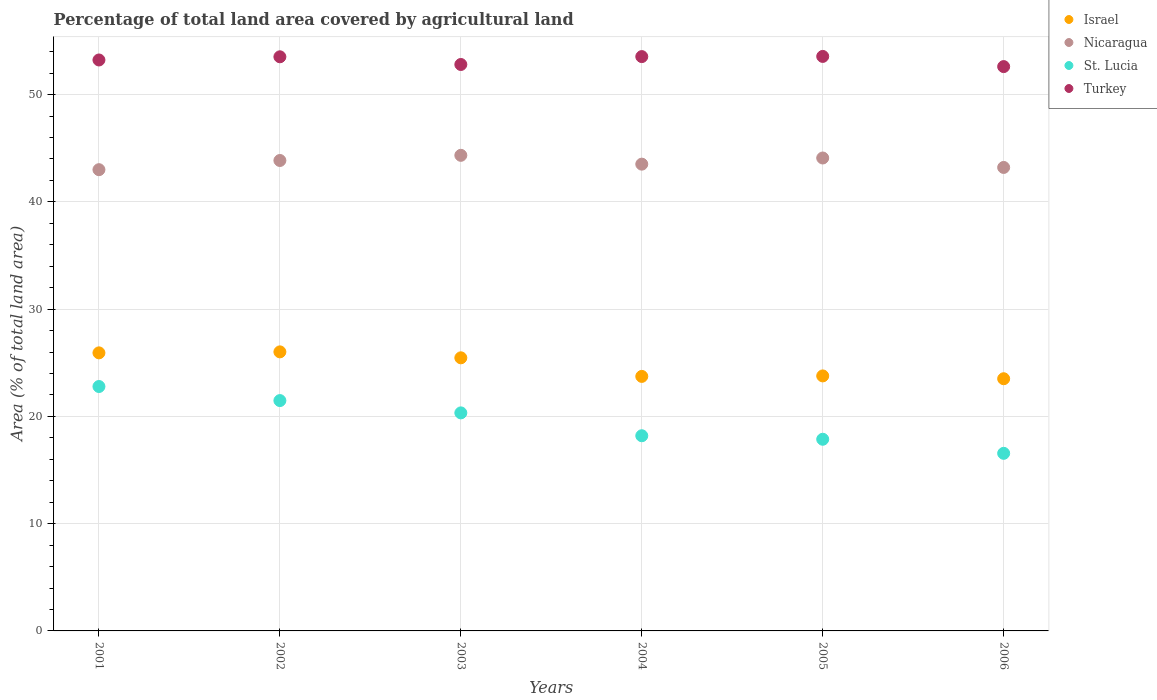What is the percentage of agricultural land in St. Lucia in 2001?
Make the answer very short. 22.79. Across all years, what is the maximum percentage of agricultural land in Turkey?
Your answer should be compact. 53.56. Across all years, what is the minimum percentage of agricultural land in Israel?
Make the answer very short. 23.51. In which year was the percentage of agricultural land in Nicaragua maximum?
Provide a succinct answer. 2003. In which year was the percentage of agricultural land in Turkey minimum?
Give a very brief answer. 2006. What is the total percentage of agricultural land in Nicaragua in the graph?
Your answer should be very brief. 262.02. What is the difference between the percentage of agricultural land in Turkey in 2001 and that in 2003?
Make the answer very short. 0.42. What is the difference between the percentage of agricultural land in Nicaragua in 2004 and the percentage of agricultural land in Turkey in 2001?
Offer a terse response. -9.71. What is the average percentage of agricultural land in St. Lucia per year?
Offer a terse response. 19.54. In the year 2002, what is the difference between the percentage of agricultural land in Israel and percentage of agricultural land in Nicaragua?
Your answer should be very brief. -17.84. What is the ratio of the percentage of agricultural land in Israel in 2001 to that in 2006?
Give a very brief answer. 1.1. Is the percentage of agricultural land in Turkey in 2005 less than that in 2006?
Your response must be concise. No. What is the difference between the highest and the second highest percentage of agricultural land in Turkey?
Keep it short and to the point. 0.02. What is the difference between the highest and the lowest percentage of agricultural land in Israel?
Ensure brevity in your answer.  2.5. Is the percentage of agricultural land in Nicaragua strictly less than the percentage of agricultural land in Israel over the years?
Keep it short and to the point. No. How many years are there in the graph?
Your answer should be compact. 6. How many legend labels are there?
Your answer should be very brief. 4. What is the title of the graph?
Offer a very short reply. Percentage of total land area covered by agricultural land. Does "Peru" appear as one of the legend labels in the graph?
Ensure brevity in your answer.  No. What is the label or title of the X-axis?
Keep it short and to the point. Years. What is the label or title of the Y-axis?
Ensure brevity in your answer.  Area (% of total land area). What is the Area (% of total land area) of Israel in 2001?
Offer a terse response. 25.92. What is the Area (% of total land area) in Nicaragua in 2001?
Offer a terse response. 43. What is the Area (% of total land area) in St. Lucia in 2001?
Offer a terse response. 22.79. What is the Area (% of total land area) of Turkey in 2001?
Provide a short and direct response. 53.23. What is the Area (% of total land area) of Israel in 2002?
Keep it short and to the point. 26.02. What is the Area (% of total land area) of Nicaragua in 2002?
Your answer should be compact. 43.86. What is the Area (% of total land area) in St. Lucia in 2002?
Make the answer very short. 21.48. What is the Area (% of total land area) of Turkey in 2002?
Provide a succinct answer. 53.53. What is the Area (% of total land area) of Israel in 2003?
Offer a terse response. 25.46. What is the Area (% of total land area) of Nicaragua in 2003?
Provide a succinct answer. 44.34. What is the Area (% of total land area) in St. Lucia in 2003?
Offer a very short reply. 20.33. What is the Area (% of total land area) of Turkey in 2003?
Ensure brevity in your answer.  52.81. What is the Area (% of total land area) of Israel in 2004?
Keep it short and to the point. 23.73. What is the Area (% of total land area) in Nicaragua in 2004?
Provide a succinct answer. 43.52. What is the Area (% of total land area) in St. Lucia in 2004?
Your response must be concise. 18.2. What is the Area (% of total land area) of Turkey in 2004?
Your answer should be very brief. 53.55. What is the Area (% of total land area) of Israel in 2005?
Keep it short and to the point. 23.78. What is the Area (% of total land area) of Nicaragua in 2005?
Your answer should be very brief. 44.09. What is the Area (% of total land area) in St. Lucia in 2005?
Your answer should be very brief. 17.87. What is the Area (% of total land area) in Turkey in 2005?
Your answer should be compact. 53.56. What is the Area (% of total land area) of Israel in 2006?
Your response must be concise. 23.51. What is the Area (% of total land area) of Nicaragua in 2006?
Your answer should be compact. 43.21. What is the Area (% of total land area) in St. Lucia in 2006?
Offer a very short reply. 16.56. What is the Area (% of total land area) in Turkey in 2006?
Your answer should be very brief. 52.61. Across all years, what is the maximum Area (% of total land area) of Israel?
Provide a succinct answer. 26.02. Across all years, what is the maximum Area (% of total land area) of Nicaragua?
Your answer should be compact. 44.34. Across all years, what is the maximum Area (% of total land area) in St. Lucia?
Your answer should be very brief. 22.79. Across all years, what is the maximum Area (% of total land area) in Turkey?
Make the answer very short. 53.56. Across all years, what is the minimum Area (% of total land area) of Israel?
Offer a terse response. 23.51. Across all years, what is the minimum Area (% of total land area) in Nicaragua?
Your answer should be very brief. 43. Across all years, what is the minimum Area (% of total land area) of St. Lucia?
Ensure brevity in your answer.  16.56. Across all years, what is the minimum Area (% of total land area) in Turkey?
Keep it short and to the point. 52.61. What is the total Area (% of total land area) in Israel in the graph?
Your answer should be compact. 148.42. What is the total Area (% of total land area) in Nicaragua in the graph?
Make the answer very short. 262.02. What is the total Area (% of total land area) of St. Lucia in the graph?
Make the answer very short. 117.21. What is the total Area (% of total land area) of Turkey in the graph?
Offer a terse response. 319.29. What is the difference between the Area (% of total land area) in Israel in 2001 and that in 2002?
Your answer should be very brief. -0.09. What is the difference between the Area (% of total land area) of Nicaragua in 2001 and that in 2002?
Ensure brevity in your answer.  -0.86. What is the difference between the Area (% of total land area) in St. Lucia in 2001 and that in 2002?
Make the answer very short. 1.31. What is the difference between the Area (% of total land area) of Turkey in 2001 and that in 2002?
Your response must be concise. -0.3. What is the difference between the Area (% of total land area) in Israel in 2001 and that in 2003?
Your answer should be compact. 0.46. What is the difference between the Area (% of total land area) in Nicaragua in 2001 and that in 2003?
Provide a short and direct response. -1.34. What is the difference between the Area (% of total land area) in St. Lucia in 2001 and that in 2003?
Provide a succinct answer. 2.46. What is the difference between the Area (% of total land area) in Turkey in 2001 and that in 2003?
Your answer should be very brief. 0.42. What is the difference between the Area (% of total land area) in Israel in 2001 and that in 2004?
Ensure brevity in your answer.  2.19. What is the difference between the Area (% of total land area) in Nicaragua in 2001 and that in 2004?
Keep it short and to the point. -0.52. What is the difference between the Area (% of total land area) in St. Lucia in 2001 and that in 2004?
Ensure brevity in your answer.  4.59. What is the difference between the Area (% of total land area) in Turkey in 2001 and that in 2004?
Give a very brief answer. -0.31. What is the difference between the Area (% of total land area) in Israel in 2001 and that in 2005?
Provide a succinct answer. 2.15. What is the difference between the Area (% of total land area) of Nicaragua in 2001 and that in 2005?
Give a very brief answer. -1.09. What is the difference between the Area (% of total land area) in St. Lucia in 2001 and that in 2005?
Provide a succinct answer. 4.92. What is the difference between the Area (% of total land area) in Turkey in 2001 and that in 2005?
Your response must be concise. -0.33. What is the difference between the Area (% of total land area) of Israel in 2001 and that in 2006?
Your answer should be very brief. 2.41. What is the difference between the Area (% of total land area) of Nicaragua in 2001 and that in 2006?
Your answer should be very brief. -0.21. What is the difference between the Area (% of total land area) of St. Lucia in 2001 and that in 2006?
Your response must be concise. 6.23. What is the difference between the Area (% of total land area) in Turkey in 2001 and that in 2006?
Give a very brief answer. 0.62. What is the difference between the Area (% of total land area) of Israel in 2002 and that in 2003?
Keep it short and to the point. 0.55. What is the difference between the Area (% of total land area) in Nicaragua in 2002 and that in 2003?
Keep it short and to the point. -0.48. What is the difference between the Area (% of total land area) of St. Lucia in 2002 and that in 2003?
Offer a terse response. 1.15. What is the difference between the Area (% of total land area) of Turkey in 2002 and that in 2003?
Keep it short and to the point. 0.72. What is the difference between the Area (% of total land area) in Israel in 2002 and that in 2004?
Provide a short and direct response. 2.29. What is the difference between the Area (% of total land area) in Nicaragua in 2002 and that in 2004?
Your response must be concise. 0.34. What is the difference between the Area (% of total land area) of St. Lucia in 2002 and that in 2004?
Give a very brief answer. 3.28. What is the difference between the Area (% of total land area) in Turkey in 2002 and that in 2004?
Your answer should be compact. -0.02. What is the difference between the Area (% of total land area) of Israel in 2002 and that in 2005?
Ensure brevity in your answer.  2.24. What is the difference between the Area (% of total land area) of Nicaragua in 2002 and that in 2005?
Your response must be concise. -0.23. What is the difference between the Area (% of total land area) in St. Lucia in 2002 and that in 2005?
Provide a succinct answer. 3.61. What is the difference between the Area (% of total land area) of Turkey in 2002 and that in 2005?
Your response must be concise. -0.04. What is the difference between the Area (% of total land area) of Israel in 2002 and that in 2006?
Provide a short and direct response. 2.5. What is the difference between the Area (% of total land area) of Nicaragua in 2002 and that in 2006?
Keep it short and to the point. 0.65. What is the difference between the Area (% of total land area) in St. Lucia in 2002 and that in 2006?
Offer a very short reply. 4.92. What is the difference between the Area (% of total land area) in Turkey in 2002 and that in 2006?
Keep it short and to the point. 0.91. What is the difference between the Area (% of total land area) in Israel in 2003 and that in 2004?
Offer a very short reply. 1.73. What is the difference between the Area (% of total land area) of Nicaragua in 2003 and that in 2004?
Make the answer very short. 0.82. What is the difference between the Area (% of total land area) in St. Lucia in 2003 and that in 2004?
Provide a short and direct response. 2.13. What is the difference between the Area (% of total land area) of Turkey in 2003 and that in 2004?
Give a very brief answer. -0.74. What is the difference between the Area (% of total land area) of Israel in 2003 and that in 2005?
Offer a terse response. 1.69. What is the difference between the Area (% of total land area) of Nicaragua in 2003 and that in 2005?
Ensure brevity in your answer.  0.25. What is the difference between the Area (% of total land area) in St. Lucia in 2003 and that in 2005?
Your answer should be compact. 2.46. What is the difference between the Area (% of total land area) in Turkey in 2003 and that in 2005?
Keep it short and to the point. -0.75. What is the difference between the Area (% of total land area) in Israel in 2003 and that in 2006?
Provide a short and direct response. 1.95. What is the difference between the Area (% of total land area) of Nicaragua in 2003 and that in 2006?
Provide a short and direct response. 1.13. What is the difference between the Area (% of total land area) of St. Lucia in 2003 and that in 2006?
Keep it short and to the point. 3.77. What is the difference between the Area (% of total land area) of Turkey in 2003 and that in 2006?
Give a very brief answer. 0.2. What is the difference between the Area (% of total land area) of Israel in 2004 and that in 2005?
Provide a short and direct response. -0.05. What is the difference between the Area (% of total land area) of Nicaragua in 2004 and that in 2005?
Provide a succinct answer. -0.57. What is the difference between the Area (% of total land area) in St. Lucia in 2004 and that in 2005?
Your answer should be very brief. 0.33. What is the difference between the Area (% of total land area) of Turkey in 2004 and that in 2005?
Give a very brief answer. -0.02. What is the difference between the Area (% of total land area) in Israel in 2004 and that in 2006?
Make the answer very short. 0.22. What is the difference between the Area (% of total land area) of Nicaragua in 2004 and that in 2006?
Provide a short and direct response. 0.31. What is the difference between the Area (% of total land area) in St. Lucia in 2004 and that in 2006?
Your response must be concise. 1.64. What is the difference between the Area (% of total land area) of Turkey in 2004 and that in 2006?
Your response must be concise. 0.93. What is the difference between the Area (% of total land area) in Israel in 2005 and that in 2006?
Ensure brevity in your answer.  0.26. What is the difference between the Area (% of total land area) of Nicaragua in 2005 and that in 2006?
Offer a terse response. 0.88. What is the difference between the Area (% of total land area) in St. Lucia in 2005 and that in 2006?
Provide a short and direct response. 1.31. What is the difference between the Area (% of total land area) of Turkey in 2005 and that in 2006?
Ensure brevity in your answer.  0.95. What is the difference between the Area (% of total land area) of Israel in 2001 and the Area (% of total land area) of Nicaragua in 2002?
Provide a short and direct response. -17.93. What is the difference between the Area (% of total land area) in Israel in 2001 and the Area (% of total land area) in St. Lucia in 2002?
Make the answer very short. 4.45. What is the difference between the Area (% of total land area) in Israel in 2001 and the Area (% of total land area) in Turkey in 2002?
Ensure brevity in your answer.  -27.6. What is the difference between the Area (% of total land area) in Nicaragua in 2001 and the Area (% of total land area) in St. Lucia in 2002?
Provide a short and direct response. 21.53. What is the difference between the Area (% of total land area) of Nicaragua in 2001 and the Area (% of total land area) of Turkey in 2002?
Provide a short and direct response. -10.52. What is the difference between the Area (% of total land area) of St. Lucia in 2001 and the Area (% of total land area) of Turkey in 2002?
Make the answer very short. -30.74. What is the difference between the Area (% of total land area) of Israel in 2001 and the Area (% of total land area) of Nicaragua in 2003?
Your answer should be compact. -18.42. What is the difference between the Area (% of total land area) in Israel in 2001 and the Area (% of total land area) in St. Lucia in 2003?
Your answer should be compact. 5.6. What is the difference between the Area (% of total land area) of Israel in 2001 and the Area (% of total land area) of Turkey in 2003?
Offer a terse response. -26.89. What is the difference between the Area (% of total land area) in Nicaragua in 2001 and the Area (% of total land area) in St. Lucia in 2003?
Your answer should be very brief. 22.68. What is the difference between the Area (% of total land area) in Nicaragua in 2001 and the Area (% of total land area) in Turkey in 2003?
Give a very brief answer. -9.81. What is the difference between the Area (% of total land area) of St. Lucia in 2001 and the Area (% of total land area) of Turkey in 2003?
Keep it short and to the point. -30.02. What is the difference between the Area (% of total land area) of Israel in 2001 and the Area (% of total land area) of Nicaragua in 2004?
Ensure brevity in your answer.  -17.59. What is the difference between the Area (% of total land area) of Israel in 2001 and the Area (% of total land area) of St. Lucia in 2004?
Offer a very short reply. 7.73. What is the difference between the Area (% of total land area) in Israel in 2001 and the Area (% of total land area) in Turkey in 2004?
Your response must be concise. -27.62. What is the difference between the Area (% of total land area) of Nicaragua in 2001 and the Area (% of total land area) of St. Lucia in 2004?
Make the answer very short. 24.81. What is the difference between the Area (% of total land area) of Nicaragua in 2001 and the Area (% of total land area) of Turkey in 2004?
Your response must be concise. -10.54. What is the difference between the Area (% of total land area) of St. Lucia in 2001 and the Area (% of total land area) of Turkey in 2004?
Ensure brevity in your answer.  -30.76. What is the difference between the Area (% of total land area) of Israel in 2001 and the Area (% of total land area) of Nicaragua in 2005?
Keep it short and to the point. -18.17. What is the difference between the Area (% of total land area) in Israel in 2001 and the Area (% of total land area) in St. Lucia in 2005?
Offer a terse response. 8.06. What is the difference between the Area (% of total land area) of Israel in 2001 and the Area (% of total land area) of Turkey in 2005?
Your response must be concise. -27.64. What is the difference between the Area (% of total land area) of Nicaragua in 2001 and the Area (% of total land area) of St. Lucia in 2005?
Your answer should be compact. 25.13. What is the difference between the Area (% of total land area) in Nicaragua in 2001 and the Area (% of total land area) in Turkey in 2005?
Your answer should be very brief. -10.56. What is the difference between the Area (% of total land area) of St. Lucia in 2001 and the Area (% of total land area) of Turkey in 2005?
Provide a succinct answer. -30.78. What is the difference between the Area (% of total land area) in Israel in 2001 and the Area (% of total land area) in Nicaragua in 2006?
Make the answer very short. -17.29. What is the difference between the Area (% of total land area) in Israel in 2001 and the Area (% of total land area) in St. Lucia in 2006?
Your answer should be compact. 9.37. What is the difference between the Area (% of total land area) in Israel in 2001 and the Area (% of total land area) in Turkey in 2006?
Your response must be concise. -26.69. What is the difference between the Area (% of total land area) in Nicaragua in 2001 and the Area (% of total land area) in St. Lucia in 2006?
Provide a succinct answer. 26.45. What is the difference between the Area (% of total land area) of Nicaragua in 2001 and the Area (% of total land area) of Turkey in 2006?
Keep it short and to the point. -9.61. What is the difference between the Area (% of total land area) of St. Lucia in 2001 and the Area (% of total land area) of Turkey in 2006?
Make the answer very short. -29.83. What is the difference between the Area (% of total land area) of Israel in 2002 and the Area (% of total land area) of Nicaragua in 2003?
Your answer should be compact. -18.32. What is the difference between the Area (% of total land area) in Israel in 2002 and the Area (% of total land area) in St. Lucia in 2003?
Offer a very short reply. 5.69. What is the difference between the Area (% of total land area) in Israel in 2002 and the Area (% of total land area) in Turkey in 2003?
Your response must be concise. -26.79. What is the difference between the Area (% of total land area) in Nicaragua in 2002 and the Area (% of total land area) in St. Lucia in 2003?
Ensure brevity in your answer.  23.53. What is the difference between the Area (% of total land area) in Nicaragua in 2002 and the Area (% of total land area) in Turkey in 2003?
Give a very brief answer. -8.95. What is the difference between the Area (% of total land area) of St. Lucia in 2002 and the Area (% of total land area) of Turkey in 2003?
Your response must be concise. -31.33. What is the difference between the Area (% of total land area) in Israel in 2002 and the Area (% of total land area) in Nicaragua in 2004?
Your answer should be compact. -17.5. What is the difference between the Area (% of total land area) of Israel in 2002 and the Area (% of total land area) of St. Lucia in 2004?
Offer a terse response. 7.82. What is the difference between the Area (% of total land area) in Israel in 2002 and the Area (% of total land area) in Turkey in 2004?
Provide a short and direct response. -27.53. What is the difference between the Area (% of total land area) of Nicaragua in 2002 and the Area (% of total land area) of St. Lucia in 2004?
Your response must be concise. 25.66. What is the difference between the Area (% of total land area) in Nicaragua in 2002 and the Area (% of total land area) in Turkey in 2004?
Give a very brief answer. -9.69. What is the difference between the Area (% of total land area) in St. Lucia in 2002 and the Area (% of total land area) in Turkey in 2004?
Make the answer very short. -32.07. What is the difference between the Area (% of total land area) in Israel in 2002 and the Area (% of total land area) in Nicaragua in 2005?
Ensure brevity in your answer.  -18.08. What is the difference between the Area (% of total land area) in Israel in 2002 and the Area (% of total land area) in St. Lucia in 2005?
Offer a very short reply. 8.15. What is the difference between the Area (% of total land area) of Israel in 2002 and the Area (% of total land area) of Turkey in 2005?
Your response must be concise. -27.55. What is the difference between the Area (% of total land area) in Nicaragua in 2002 and the Area (% of total land area) in St. Lucia in 2005?
Offer a very short reply. 25.99. What is the difference between the Area (% of total land area) in Nicaragua in 2002 and the Area (% of total land area) in Turkey in 2005?
Your response must be concise. -9.7. What is the difference between the Area (% of total land area) of St. Lucia in 2002 and the Area (% of total land area) of Turkey in 2005?
Your answer should be very brief. -32.09. What is the difference between the Area (% of total land area) in Israel in 2002 and the Area (% of total land area) in Nicaragua in 2006?
Your answer should be very brief. -17.19. What is the difference between the Area (% of total land area) of Israel in 2002 and the Area (% of total land area) of St. Lucia in 2006?
Your answer should be compact. 9.46. What is the difference between the Area (% of total land area) in Israel in 2002 and the Area (% of total land area) in Turkey in 2006?
Your answer should be very brief. -26.6. What is the difference between the Area (% of total land area) in Nicaragua in 2002 and the Area (% of total land area) in St. Lucia in 2006?
Ensure brevity in your answer.  27.3. What is the difference between the Area (% of total land area) in Nicaragua in 2002 and the Area (% of total land area) in Turkey in 2006?
Your response must be concise. -8.75. What is the difference between the Area (% of total land area) of St. Lucia in 2002 and the Area (% of total land area) of Turkey in 2006?
Provide a short and direct response. -31.14. What is the difference between the Area (% of total land area) in Israel in 2003 and the Area (% of total land area) in Nicaragua in 2004?
Provide a short and direct response. -18.06. What is the difference between the Area (% of total land area) in Israel in 2003 and the Area (% of total land area) in St. Lucia in 2004?
Ensure brevity in your answer.  7.27. What is the difference between the Area (% of total land area) of Israel in 2003 and the Area (% of total land area) of Turkey in 2004?
Your answer should be very brief. -28.08. What is the difference between the Area (% of total land area) in Nicaragua in 2003 and the Area (% of total land area) in St. Lucia in 2004?
Offer a terse response. 26.14. What is the difference between the Area (% of total land area) of Nicaragua in 2003 and the Area (% of total land area) of Turkey in 2004?
Offer a very short reply. -9.2. What is the difference between the Area (% of total land area) in St. Lucia in 2003 and the Area (% of total land area) in Turkey in 2004?
Provide a succinct answer. -33.22. What is the difference between the Area (% of total land area) of Israel in 2003 and the Area (% of total land area) of Nicaragua in 2005?
Your answer should be very brief. -18.63. What is the difference between the Area (% of total land area) in Israel in 2003 and the Area (% of total land area) in St. Lucia in 2005?
Your response must be concise. 7.59. What is the difference between the Area (% of total land area) in Israel in 2003 and the Area (% of total land area) in Turkey in 2005?
Offer a very short reply. -28.1. What is the difference between the Area (% of total land area) of Nicaragua in 2003 and the Area (% of total land area) of St. Lucia in 2005?
Your answer should be compact. 26.47. What is the difference between the Area (% of total land area) of Nicaragua in 2003 and the Area (% of total land area) of Turkey in 2005?
Offer a very short reply. -9.22. What is the difference between the Area (% of total land area) of St. Lucia in 2003 and the Area (% of total land area) of Turkey in 2005?
Give a very brief answer. -33.23. What is the difference between the Area (% of total land area) of Israel in 2003 and the Area (% of total land area) of Nicaragua in 2006?
Provide a short and direct response. -17.75. What is the difference between the Area (% of total land area) of Israel in 2003 and the Area (% of total land area) of St. Lucia in 2006?
Give a very brief answer. 8.9. What is the difference between the Area (% of total land area) in Israel in 2003 and the Area (% of total land area) in Turkey in 2006?
Provide a succinct answer. -27.15. What is the difference between the Area (% of total land area) of Nicaragua in 2003 and the Area (% of total land area) of St. Lucia in 2006?
Your answer should be very brief. 27.78. What is the difference between the Area (% of total land area) of Nicaragua in 2003 and the Area (% of total land area) of Turkey in 2006?
Make the answer very short. -8.27. What is the difference between the Area (% of total land area) of St. Lucia in 2003 and the Area (% of total land area) of Turkey in 2006?
Give a very brief answer. -32.29. What is the difference between the Area (% of total land area) in Israel in 2004 and the Area (% of total land area) in Nicaragua in 2005?
Your answer should be compact. -20.36. What is the difference between the Area (% of total land area) in Israel in 2004 and the Area (% of total land area) in St. Lucia in 2005?
Your answer should be very brief. 5.86. What is the difference between the Area (% of total land area) of Israel in 2004 and the Area (% of total land area) of Turkey in 2005?
Provide a succinct answer. -29.83. What is the difference between the Area (% of total land area) in Nicaragua in 2004 and the Area (% of total land area) in St. Lucia in 2005?
Give a very brief answer. 25.65. What is the difference between the Area (% of total land area) of Nicaragua in 2004 and the Area (% of total land area) of Turkey in 2005?
Ensure brevity in your answer.  -10.04. What is the difference between the Area (% of total land area) of St. Lucia in 2004 and the Area (% of total land area) of Turkey in 2005?
Your answer should be compact. -35.37. What is the difference between the Area (% of total land area) of Israel in 2004 and the Area (% of total land area) of Nicaragua in 2006?
Ensure brevity in your answer.  -19.48. What is the difference between the Area (% of total land area) of Israel in 2004 and the Area (% of total land area) of St. Lucia in 2006?
Give a very brief answer. 7.17. What is the difference between the Area (% of total land area) in Israel in 2004 and the Area (% of total land area) in Turkey in 2006?
Your answer should be very brief. -28.88. What is the difference between the Area (% of total land area) in Nicaragua in 2004 and the Area (% of total land area) in St. Lucia in 2006?
Provide a short and direct response. 26.96. What is the difference between the Area (% of total land area) in Nicaragua in 2004 and the Area (% of total land area) in Turkey in 2006?
Offer a very short reply. -9.1. What is the difference between the Area (% of total land area) of St. Lucia in 2004 and the Area (% of total land area) of Turkey in 2006?
Keep it short and to the point. -34.42. What is the difference between the Area (% of total land area) in Israel in 2005 and the Area (% of total land area) in Nicaragua in 2006?
Provide a succinct answer. -19.44. What is the difference between the Area (% of total land area) of Israel in 2005 and the Area (% of total land area) of St. Lucia in 2006?
Make the answer very short. 7.22. What is the difference between the Area (% of total land area) in Israel in 2005 and the Area (% of total land area) in Turkey in 2006?
Make the answer very short. -28.84. What is the difference between the Area (% of total land area) of Nicaragua in 2005 and the Area (% of total land area) of St. Lucia in 2006?
Your answer should be very brief. 27.53. What is the difference between the Area (% of total land area) in Nicaragua in 2005 and the Area (% of total land area) in Turkey in 2006?
Provide a succinct answer. -8.52. What is the difference between the Area (% of total land area) of St. Lucia in 2005 and the Area (% of total land area) of Turkey in 2006?
Offer a very short reply. -34.74. What is the average Area (% of total land area) in Israel per year?
Your answer should be compact. 24.74. What is the average Area (% of total land area) of Nicaragua per year?
Offer a very short reply. 43.67. What is the average Area (% of total land area) in St. Lucia per year?
Keep it short and to the point. 19.54. What is the average Area (% of total land area) of Turkey per year?
Provide a succinct answer. 53.21. In the year 2001, what is the difference between the Area (% of total land area) in Israel and Area (% of total land area) in Nicaragua?
Your answer should be compact. -17.08. In the year 2001, what is the difference between the Area (% of total land area) in Israel and Area (% of total land area) in St. Lucia?
Your response must be concise. 3.14. In the year 2001, what is the difference between the Area (% of total land area) of Israel and Area (% of total land area) of Turkey?
Offer a very short reply. -27.31. In the year 2001, what is the difference between the Area (% of total land area) of Nicaragua and Area (% of total land area) of St. Lucia?
Your response must be concise. 20.22. In the year 2001, what is the difference between the Area (% of total land area) in Nicaragua and Area (% of total land area) in Turkey?
Provide a succinct answer. -10.23. In the year 2001, what is the difference between the Area (% of total land area) in St. Lucia and Area (% of total land area) in Turkey?
Give a very brief answer. -30.44. In the year 2002, what is the difference between the Area (% of total land area) in Israel and Area (% of total land area) in Nicaragua?
Your answer should be very brief. -17.84. In the year 2002, what is the difference between the Area (% of total land area) of Israel and Area (% of total land area) of St. Lucia?
Your response must be concise. 4.54. In the year 2002, what is the difference between the Area (% of total land area) of Israel and Area (% of total land area) of Turkey?
Offer a very short reply. -27.51. In the year 2002, what is the difference between the Area (% of total land area) of Nicaragua and Area (% of total land area) of St. Lucia?
Provide a short and direct response. 22.38. In the year 2002, what is the difference between the Area (% of total land area) in Nicaragua and Area (% of total land area) in Turkey?
Keep it short and to the point. -9.67. In the year 2002, what is the difference between the Area (% of total land area) of St. Lucia and Area (% of total land area) of Turkey?
Offer a terse response. -32.05. In the year 2003, what is the difference between the Area (% of total land area) in Israel and Area (% of total land area) in Nicaragua?
Give a very brief answer. -18.88. In the year 2003, what is the difference between the Area (% of total land area) in Israel and Area (% of total land area) in St. Lucia?
Your answer should be compact. 5.13. In the year 2003, what is the difference between the Area (% of total land area) in Israel and Area (% of total land area) in Turkey?
Ensure brevity in your answer.  -27.35. In the year 2003, what is the difference between the Area (% of total land area) of Nicaragua and Area (% of total land area) of St. Lucia?
Give a very brief answer. 24.01. In the year 2003, what is the difference between the Area (% of total land area) of Nicaragua and Area (% of total land area) of Turkey?
Give a very brief answer. -8.47. In the year 2003, what is the difference between the Area (% of total land area) of St. Lucia and Area (% of total land area) of Turkey?
Make the answer very short. -32.48. In the year 2004, what is the difference between the Area (% of total land area) in Israel and Area (% of total land area) in Nicaragua?
Your answer should be compact. -19.79. In the year 2004, what is the difference between the Area (% of total land area) of Israel and Area (% of total land area) of St. Lucia?
Provide a succinct answer. 5.53. In the year 2004, what is the difference between the Area (% of total land area) of Israel and Area (% of total land area) of Turkey?
Ensure brevity in your answer.  -29.82. In the year 2004, what is the difference between the Area (% of total land area) of Nicaragua and Area (% of total land area) of St. Lucia?
Ensure brevity in your answer.  25.32. In the year 2004, what is the difference between the Area (% of total land area) in Nicaragua and Area (% of total land area) in Turkey?
Ensure brevity in your answer.  -10.03. In the year 2004, what is the difference between the Area (% of total land area) in St. Lucia and Area (% of total land area) in Turkey?
Your answer should be compact. -35.35. In the year 2005, what is the difference between the Area (% of total land area) of Israel and Area (% of total land area) of Nicaragua?
Offer a very short reply. -20.32. In the year 2005, what is the difference between the Area (% of total land area) in Israel and Area (% of total land area) in St. Lucia?
Your answer should be very brief. 5.91. In the year 2005, what is the difference between the Area (% of total land area) of Israel and Area (% of total land area) of Turkey?
Offer a terse response. -29.79. In the year 2005, what is the difference between the Area (% of total land area) in Nicaragua and Area (% of total land area) in St. Lucia?
Offer a very short reply. 26.22. In the year 2005, what is the difference between the Area (% of total land area) in Nicaragua and Area (% of total land area) in Turkey?
Provide a succinct answer. -9.47. In the year 2005, what is the difference between the Area (% of total land area) of St. Lucia and Area (% of total land area) of Turkey?
Provide a succinct answer. -35.69. In the year 2006, what is the difference between the Area (% of total land area) in Israel and Area (% of total land area) in Nicaragua?
Your answer should be very brief. -19.7. In the year 2006, what is the difference between the Area (% of total land area) of Israel and Area (% of total land area) of St. Lucia?
Your response must be concise. 6.95. In the year 2006, what is the difference between the Area (% of total land area) of Israel and Area (% of total land area) of Turkey?
Give a very brief answer. -29.1. In the year 2006, what is the difference between the Area (% of total land area) of Nicaragua and Area (% of total land area) of St. Lucia?
Your answer should be very brief. 26.65. In the year 2006, what is the difference between the Area (% of total land area) of Nicaragua and Area (% of total land area) of Turkey?
Give a very brief answer. -9.4. In the year 2006, what is the difference between the Area (% of total land area) in St. Lucia and Area (% of total land area) in Turkey?
Give a very brief answer. -36.06. What is the ratio of the Area (% of total land area) in Israel in 2001 to that in 2002?
Give a very brief answer. 1. What is the ratio of the Area (% of total land area) of Nicaragua in 2001 to that in 2002?
Your answer should be very brief. 0.98. What is the ratio of the Area (% of total land area) of St. Lucia in 2001 to that in 2002?
Make the answer very short. 1.06. What is the ratio of the Area (% of total land area) of Israel in 2001 to that in 2003?
Your answer should be very brief. 1.02. What is the ratio of the Area (% of total land area) in Nicaragua in 2001 to that in 2003?
Ensure brevity in your answer.  0.97. What is the ratio of the Area (% of total land area) of St. Lucia in 2001 to that in 2003?
Your answer should be compact. 1.12. What is the ratio of the Area (% of total land area) of Turkey in 2001 to that in 2003?
Your response must be concise. 1.01. What is the ratio of the Area (% of total land area) of Israel in 2001 to that in 2004?
Offer a terse response. 1.09. What is the ratio of the Area (% of total land area) of St. Lucia in 2001 to that in 2004?
Ensure brevity in your answer.  1.25. What is the ratio of the Area (% of total land area) in Turkey in 2001 to that in 2004?
Offer a terse response. 0.99. What is the ratio of the Area (% of total land area) in Israel in 2001 to that in 2005?
Give a very brief answer. 1.09. What is the ratio of the Area (% of total land area) of Nicaragua in 2001 to that in 2005?
Keep it short and to the point. 0.98. What is the ratio of the Area (% of total land area) of St. Lucia in 2001 to that in 2005?
Your response must be concise. 1.28. What is the ratio of the Area (% of total land area) in Turkey in 2001 to that in 2005?
Ensure brevity in your answer.  0.99. What is the ratio of the Area (% of total land area) in Israel in 2001 to that in 2006?
Provide a succinct answer. 1.1. What is the ratio of the Area (% of total land area) of St. Lucia in 2001 to that in 2006?
Your answer should be very brief. 1.38. What is the ratio of the Area (% of total land area) in Turkey in 2001 to that in 2006?
Offer a very short reply. 1.01. What is the ratio of the Area (% of total land area) in Israel in 2002 to that in 2003?
Give a very brief answer. 1.02. What is the ratio of the Area (% of total land area) of Nicaragua in 2002 to that in 2003?
Ensure brevity in your answer.  0.99. What is the ratio of the Area (% of total land area) in St. Lucia in 2002 to that in 2003?
Give a very brief answer. 1.06. What is the ratio of the Area (% of total land area) of Turkey in 2002 to that in 2003?
Provide a succinct answer. 1.01. What is the ratio of the Area (% of total land area) in Israel in 2002 to that in 2004?
Offer a very short reply. 1.1. What is the ratio of the Area (% of total land area) in Nicaragua in 2002 to that in 2004?
Provide a short and direct response. 1.01. What is the ratio of the Area (% of total land area) of St. Lucia in 2002 to that in 2004?
Make the answer very short. 1.18. What is the ratio of the Area (% of total land area) in Israel in 2002 to that in 2005?
Your answer should be compact. 1.09. What is the ratio of the Area (% of total land area) of Nicaragua in 2002 to that in 2005?
Provide a short and direct response. 0.99. What is the ratio of the Area (% of total land area) in St. Lucia in 2002 to that in 2005?
Ensure brevity in your answer.  1.2. What is the ratio of the Area (% of total land area) of Israel in 2002 to that in 2006?
Give a very brief answer. 1.11. What is the ratio of the Area (% of total land area) of Nicaragua in 2002 to that in 2006?
Your answer should be compact. 1.01. What is the ratio of the Area (% of total land area) in St. Lucia in 2002 to that in 2006?
Offer a terse response. 1.3. What is the ratio of the Area (% of total land area) of Turkey in 2002 to that in 2006?
Offer a very short reply. 1.02. What is the ratio of the Area (% of total land area) in Israel in 2003 to that in 2004?
Make the answer very short. 1.07. What is the ratio of the Area (% of total land area) of Nicaragua in 2003 to that in 2004?
Your answer should be compact. 1.02. What is the ratio of the Area (% of total land area) of St. Lucia in 2003 to that in 2004?
Your answer should be compact. 1.12. What is the ratio of the Area (% of total land area) of Turkey in 2003 to that in 2004?
Your answer should be compact. 0.99. What is the ratio of the Area (% of total land area) in Israel in 2003 to that in 2005?
Offer a very short reply. 1.07. What is the ratio of the Area (% of total land area) in Nicaragua in 2003 to that in 2005?
Provide a short and direct response. 1.01. What is the ratio of the Area (% of total land area) of St. Lucia in 2003 to that in 2005?
Offer a very short reply. 1.14. What is the ratio of the Area (% of total land area) of Israel in 2003 to that in 2006?
Your response must be concise. 1.08. What is the ratio of the Area (% of total land area) of Nicaragua in 2003 to that in 2006?
Make the answer very short. 1.03. What is the ratio of the Area (% of total land area) in St. Lucia in 2003 to that in 2006?
Ensure brevity in your answer.  1.23. What is the ratio of the Area (% of total land area) in Turkey in 2003 to that in 2006?
Provide a succinct answer. 1. What is the ratio of the Area (% of total land area) in Israel in 2004 to that in 2005?
Keep it short and to the point. 1. What is the ratio of the Area (% of total land area) of Nicaragua in 2004 to that in 2005?
Make the answer very short. 0.99. What is the ratio of the Area (% of total land area) in St. Lucia in 2004 to that in 2005?
Offer a very short reply. 1.02. What is the ratio of the Area (% of total land area) in Turkey in 2004 to that in 2005?
Your answer should be very brief. 1. What is the ratio of the Area (% of total land area) of Israel in 2004 to that in 2006?
Give a very brief answer. 1.01. What is the ratio of the Area (% of total land area) in Nicaragua in 2004 to that in 2006?
Your answer should be compact. 1.01. What is the ratio of the Area (% of total land area) in St. Lucia in 2004 to that in 2006?
Give a very brief answer. 1.1. What is the ratio of the Area (% of total land area) in Turkey in 2004 to that in 2006?
Offer a terse response. 1.02. What is the ratio of the Area (% of total land area) of Israel in 2005 to that in 2006?
Give a very brief answer. 1.01. What is the ratio of the Area (% of total land area) in Nicaragua in 2005 to that in 2006?
Give a very brief answer. 1.02. What is the ratio of the Area (% of total land area) of St. Lucia in 2005 to that in 2006?
Your answer should be compact. 1.08. What is the ratio of the Area (% of total land area) in Turkey in 2005 to that in 2006?
Make the answer very short. 1.02. What is the difference between the highest and the second highest Area (% of total land area) in Israel?
Offer a very short reply. 0.09. What is the difference between the highest and the second highest Area (% of total land area) in Nicaragua?
Ensure brevity in your answer.  0.25. What is the difference between the highest and the second highest Area (% of total land area) of St. Lucia?
Give a very brief answer. 1.31. What is the difference between the highest and the second highest Area (% of total land area) of Turkey?
Your answer should be very brief. 0.02. What is the difference between the highest and the lowest Area (% of total land area) of Israel?
Provide a succinct answer. 2.5. What is the difference between the highest and the lowest Area (% of total land area) of Nicaragua?
Your answer should be very brief. 1.34. What is the difference between the highest and the lowest Area (% of total land area) in St. Lucia?
Your response must be concise. 6.23. What is the difference between the highest and the lowest Area (% of total land area) in Turkey?
Offer a terse response. 0.95. 